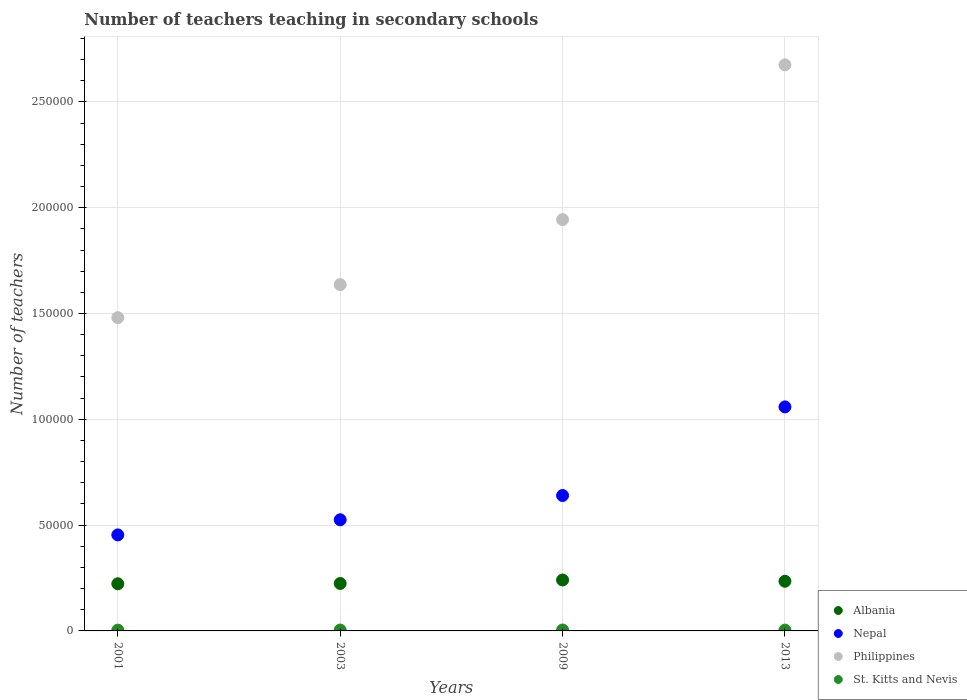How many different coloured dotlines are there?
Keep it short and to the point. 4. Is the number of dotlines equal to the number of legend labels?
Give a very brief answer. Yes. What is the number of teachers teaching in secondary schools in Philippines in 2009?
Your answer should be very brief. 1.94e+05. Across all years, what is the maximum number of teachers teaching in secondary schools in Albania?
Ensure brevity in your answer.  2.41e+04. Across all years, what is the minimum number of teachers teaching in secondary schools in St. Kitts and Nevis?
Your answer should be compact. 376. In which year was the number of teachers teaching in secondary schools in St. Kitts and Nevis maximum?
Your answer should be compact. 2009. What is the total number of teachers teaching in secondary schools in Philippines in the graph?
Keep it short and to the point. 7.74e+05. What is the difference between the number of teachers teaching in secondary schools in Albania in 2003 and that in 2009?
Your answer should be compact. -1645. What is the difference between the number of teachers teaching in secondary schools in Nepal in 2003 and the number of teachers teaching in secondary schools in St. Kitts and Nevis in 2009?
Offer a terse response. 5.21e+04. What is the average number of teachers teaching in secondary schools in Albania per year?
Offer a terse response. 2.31e+04. In the year 2009, what is the difference between the number of teachers teaching in secondary schools in Albania and number of teachers teaching in secondary schools in Philippines?
Your response must be concise. -1.70e+05. What is the ratio of the number of teachers teaching in secondary schools in Nepal in 2001 to that in 2003?
Offer a terse response. 0.86. Is the difference between the number of teachers teaching in secondary schools in Albania in 2003 and 2009 greater than the difference between the number of teachers teaching in secondary schools in Philippines in 2003 and 2009?
Ensure brevity in your answer.  Yes. What is the difference between the highest and the lowest number of teachers teaching in secondary schools in Philippines?
Keep it short and to the point. 1.19e+05. Is it the case that in every year, the sum of the number of teachers teaching in secondary schools in Nepal and number of teachers teaching in secondary schools in Philippines  is greater than the sum of number of teachers teaching in secondary schools in Albania and number of teachers teaching in secondary schools in St. Kitts and Nevis?
Ensure brevity in your answer.  No. Does the number of teachers teaching in secondary schools in Nepal monotonically increase over the years?
Make the answer very short. Yes. Is the number of teachers teaching in secondary schools in Philippines strictly greater than the number of teachers teaching in secondary schools in Albania over the years?
Keep it short and to the point. Yes. Are the values on the major ticks of Y-axis written in scientific E-notation?
Your response must be concise. No. How many legend labels are there?
Your answer should be compact. 4. How are the legend labels stacked?
Keep it short and to the point. Vertical. What is the title of the graph?
Provide a succinct answer. Number of teachers teaching in secondary schools. What is the label or title of the Y-axis?
Your answer should be compact. Number of teachers. What is the Number of teachers of Albania in 2001?
Offer a terse response. 2.23e+04. What is the Number of teachers in Nepal in 2001?
Provide a short and direct response. 4.54e+04. What is the Number of teachers in Philippines in 2001?
Your response must be concise. 1.48e+05. What is the Number of teachers of St. Kitts and Nevis in 2001?
Provide a succinct answer. 376. What is the Number of teachers of Albania in 2003?
Offer a terse response. 2.24e+04. What is the Number of teachers of Nepal in 2003?
Provide a short and direct response. 5.25e+04. What is the Number of teachers of Philippines in 2003?
Provide a short and direct response. 1.64e+05. What is the Number of teachers in St. Kitts and Nevis in 2003?
Your response must be concise. 417. What is the Number of teachers in Albania in 2009?
Give a very brief answer. 2.41e+04. What is the Number of teachers in Nepal in 2009?
Your response must be concise. 6.40e+04. What is the Number of teachers in Philippines in 2009?
Your response must be concise. 1.94e+05. What is the Number of teachers of St. Kitts and Nevis in 2009?
Your answer should be very brief. 441. What is the Number of teachers in Albania in 2013?
Provide a succinct answer. 2.35e+04. What is the Number of teachers of Nepal in 2013?
Ensure brevity in your answer.  1.06e+05. What is the Number of teachers in Philippines in 2013?
Make the answer very short. 2.68e+05. What is the Number of teachers of St. Kitts and Nevis in 2013?
Ensure brevity in your answer.  386. Across all years, what is the maximum Number of teachers of Albania?
Your answer should be very brief. 2.41e+04. Across all years, what is the maximum Number of teachers in Nepal?
Offer a terse response. 1.06e+05. Across all years, what is the maximum Number of teachers in Philippines?
Your answer should be compact. 2.68e+05. Across all years, what is the maximum Number of teachers of St. Kitts and Nevis?
Offer a terse response. 441. Across all years, what is the minimum Number of teachers in Albania?
Your response must be concise. 2.23e+04. Across all years, what is the minimum Number of teachers in Nepal?
Keep it short and to the point. 4.54e+04. Across all years, what is the minimum Number of teachers in Philippines?
Offer a very short reply. 1.48e+05. Across all years, what is the minimum Number of teachers of St. Kitts and Nevis?
Give a very brief answer. 376. What is the total Number of teachers in Albania in the graph?
Your answer should be very brief. 9.22e+04. What is the total Number of teachers of Nepal in the graph?
Provide a short and direct response. 2.68e+05. What is the total Number of teachers of Philippines in the graph?
Keep it short and to the point. 7.74e+05. What is the total Number of teachers in St. Kitts and Nevis in the graph?
Offer a very short reply. 1620. What is the difference between the Number of teachers in Albania in 2001 and that in 2003?
Your answer should be very brief. -144. What is the difference between the Number of teachers of Nepal in 2001 and that in 2003?
Your answer should be compact. -7155. What is the difference between the Number of teachers of Philippines in 2001 and that in 2003?
Your response must be concise. -1.56e+04. What is the difference between the Number of teachers of St. Kitts and Nevis in 2001 and that in 2003?
Provide a succinct answer. -41. What is the difference between the Number of teachers in Albania in 2001 and that in 2009?
Provide a succinct answer. -1789. What is the difference between the Number of teachers in Nepal in 2001 and that in 2009?
Provide a succinct answer. -1.86e+04. What is the difference between the Number of teachers in Philippines in 2001 and that in 2009?
Ensure brevity in your answer.  -4.63e+04. What is the difference between the Number of teachers of St. Kitts and Nevis in 2001 and that in 2009?
Provide a short and direct response. -65. What is the difference between the Number of teachers in Albania in 2001 and that in 2013?
Give a very brief answer. -1191. What is the difference between the Number of teachers in Nepal in 2001 and that in 2013?
Provide a succinct answer. -6.05e+04. What is the difference between the Number of teachers of Philippines in 2001 and that in 2013?
Make the answer very short. -1.19e+05. What is the difference between the Number of teachers of St. Kitts and Nevis in 2001 and that in 2013?
Your answer should be compact. -10. What is the difference between the Number of teachers of Albania in 2003 and that in 2009?
Ensure brevity in your answer.  -1645. What is the difference between the Number of teachers of Nepal in 2003 and that in 2009?
Provide a succinct answer. -1.15e+04. What is the difference between the Number of teachers of Philippines in 2003 and that in 2009?
Offer a very short reply. -3.07e+04. What is the difference between the Number of teachers in St. Kitts and Nevis in 2003 and that in 2009?
Offer a very short reply. -24. What is the difference between the Number of teachers of Albania in 2003 and that in 2013?
Ensure brevity in your answer.  -1047. What is the difference between the Number of teachers of Nepal in 2003 and that in 2013?
Make the answer very short. -5.33e+04. What is the difference between the Number of teachers in Philippines in 2003 and that in 2013?
Make the answer very short. -1.04e+05. What is the difference between the Number of teachers in St. Kitts and Nevis in 2003 and that in 2013?
Give a very brief answer. 31. What is the difference between the Number of teachers of Albania in 2009 and that in 2013?
Your answer should be very brief. 598. What is the difference between the Number of teachers in Nepal in 2009 and that in 2013?
Provide a short and direct response. -4.19e+04. What is the difference between the Number of teachers of Philippines in 2009 and that in 2013?
Keep it short and to the point. -7.31e+04. What is the difference between the Number of teachers of St. Kitts and Nevis in 2009 and that in 2013?
Your answer should be very brief. 55. What is the difference between the Number of teachers in Albania in 2001 and the Number of teachers in Nepal in 2003?
Give a very brief answer. -3.02e+04. What is the difference between the Number of teachers of Albania in 2001 and the Number of teachers of Philippines in 2003?
Ensure brevity in your answer.  -1.41e+05. What is the difference between the Number of teachers of Albania in 2001 and the Number of teachers of St. Kitts and Nevis in 2003?
Provide a short and direct response. 2.19e+04. What is the difference between the Number of teachers of Nepal in 2001 and the Number of teachers of Philippines in 2003?
Provide a short and direct response. -1.18e+05. What is the difference between the Number of teachers in Nepal in 2001 and the Number of teachers in St. Kitts and Nevis in 2003?
Give a very brief answer. 4.50e+04. What is the difference between the Number of teachers in Philippines in 2001 and the Number of teachers in St. Kitts and Nevis in 2003?
Keep it short and to the point. 1.48e+05. What is the difference between the Number of teachers in Albania in 2001 and the Number of teachers in Nepal in 2009?
Provide a short and direct response. -4.17e+04. What is the difference between the Number of teachers in Albania in 2001 and the Number of teachers in Philippines in 2009?
Offer a terse response. -1.72e+05. What is the difference between the Number of teachers in Albania in 2001 and the Number of teachers in St. Kitts and Nevis in 2009?
Give a very brief answer. 2.18e+04. What is the difference between the Number of teachers in Nepal in 2001 and the Number of teachers in Philippines in 2009?
Your response must be concise. -1.49e+05. What is the difference between the Number of teachers of Nepal in 2001 and the Number of teachers of St. Kitts and Nevis in 2009?
Provide a short and direct response. 4.49e+04. What is the difference between the Number of teachers of Philippines in 2001 and the Number of teachers of St. Kitts and Nevis in 2009?
Offer a very short reply. 1.48e+05. What is the difference between the Number of teachers of Albania in 2001 and the Number of teachers of Nepal in 2013?
Provide a succinct answer. -8.36e+04. What is the difference between the Number of teachers of Albania in 2001 and the Number of teachers of Philippines in 2013?
Offer a terse response. -2.45e+05. What is the difference between the Number of teachers in Albania in 2001 and the Number of teachers in St. Kitts and Nevis in 2013?
Your answer should be very brief. 2.19e+04. What is the difference between the Number of teachers of Nepal in 2001 and the Number of teachers of Philippines in 2013?
Provide a succinct answer. -2.22e+05. What is the difference between the Number of teachers of Nepal in 2001 and the Number of teachers of St. Kitts and Nevis in 2013?
Keep it short and to the point. 4.50e+04. What is the difference between the Number of teachers of Philippines in 2001 and the Number of teachers of St. Kitts and Nevis in 2013?
Give a very brief answer. 1.48e+05. What is the difference between the Number of teachers of Albania in 2003 and the Number of teachers of Nepal in 2009?
Offer a very short reply. -4.16e+04. What is the difference between the Number of teachers of Albania in 2003 and the Number of teachers of Philippines in 2009?
Your answer should be compact. -1.72e+05. What is the difference between the Number of teachers in Albania in 2003 and the Number of teachers in St. Kitts and Nevis in 2009?
Your response must be concise. 2.20e+04. What is the difference between the Number of teachers in Nepal in 2003 and the Number of teachers in Philippines in 2009?
Your response must be concise. -1.42e+05. What is the difference between the Number of teachers in Nepal in 2003 and the Number of teachers in St. Kitts and Nevis in 2009?
Your response must be concise. 5.21e+04. What is the difference between the Number of teachers in Philippines in 2003 and the Number of teachers in St. Kitts and Nevis in 2009?
Ensure brevity in your answer.  1.63e+05. What is the difference between the Number of teachers in Albania in 2003 and the Number of teachers in Nepal in 2013?
Ensure brevity in your answer.  -8.34e+04. What is the difference between the Number of teachers of Albania in 2003 and the Number of teachers of Philippines in 2013?
Your response must be concise. -2.45e+05. What is the difference between the Number of teachers in Albania in 2003 and the Number of teachers in St. Kitts and Nevis in 2013?
Give a very brief answer. 2.20e+04. What is the difference between the Number of teachers of Nepal in 2003 and the Number of teachers of Philippines in 2013?
Offer a very short reply. -2.15e+05. What is the difference between the Number of teachers of Nepal in 2003 and the Number of teachers of St. Kitts and Nevis in 2013?
Give a very brief answer. 5.21e+04. What is the difference between the Number of teachers in Philippines in 2003 and the Number of teachers in St. Kitts and Nevis in 2013?
Ensure brevity in your answer.  1.63e+05. What is the difference between the Number of teachers in Albania in 2009 and the Number of teachers in Nepal in 2013?
Provide a succinct answer. -8.18e+04. What is the difference between the Number of teachers of Albania in 2009 and the Number of teachers of Philippines in 2013?
Provide a succinct answer. -2.43e+05. What is the difference between the Number of teachers in Albania in 2009 and the Number of teachers in St. Kitts and Nevis in 2013?
Ensure brevity in your answer.  2.37e+04. What is the difference between the Number of teachers in Nepal in 2009 and the Number of teachers in Philippines in 2013?
Give a very brief answer. -2.04e+05. What is the difference between the Number of teachers of Nepal in 2009 and the Number of teachers of St. Kitts and Nevis in 2013?
Your answer should be very brief. 6.36e+04. What is the difference between the Number of teachers of Philippines in 2009 and the Number of teachers of St. Kitts and Nevis in 2013?
Provide a short and direct response. 1.94e+05. What is the average Number of teachers in Albania per year?
Your response must be concise. 2.31e+04. What is the average Number of teachers of Nepal per year?
Offer a very short reply. 6.69e+04. What is the average Number of teachers in Philippines per year?
Provide a short and direct response. 1.93e+05. What is the average Number of teachers of St. Kitts and Nevis per year?
Your answer should be compact. 405. In the year 2001, what is the difference between the Number of teachers of Albania and Number of teachers of Nepal?
Keep it short and to the point. -2.31e+04. In the year 2001, what is the difference between the Number of teachers in Albania and Number of teachers in Philippines?
Offer a terse response. -1.26e+05. In the year 2001, what is the difference between the Number of teachers of Albania and Number of teachers of St. Kitts and Nevis?
Offer a terse response. 2.19e+04. In the year 2001, what is the difference between the Number of teachers of Nepal and Number of teachers of Philippines?
Keep it short and to the point. -1.03e+05. In the year 2001, what is the difference between the Number of teachers of Nepal and Number of teachers of St. Kitts and Nevis?
Keep it short and to the point. 4.50e+04. In the year 2001, what is the difference between the Number of teachers of Philippines and Number of teachers of St. Kitts and Nevis?
Your response must be concise. 1.48e+05. In the year 2003, what is the difference between the Number of teachers in Albania and Number of teachers in Nepal?
Give a very brief answer. -3.01e+04. In the year 2003, what is the difference between the Number of teachers in Albania and Number of teachers in Philippines?
Make the answer very short. -1.41e+05. In the year 2003, what is the difference between the Number of teachers of Albania and Number of teachers of St. Kitts and Nevis?
Provide a succinct answer. 2.20e+04. In the year 2003, what is the difference between the Number of teachers of Nepal and Number of teachers of Philippines?
Give a very brief answer. -1.11e+05. In the year 2003, what is the difference between the Number of teachers in Nepal and Number of teachers in St. Kitts and Nevis?
Your answer should be compact. 5.21e+04. In the year 2003, what is the difference between the Number of teachers of Philippines and Number of teachers of St. Kitts and Nevis?
Provide a short and direct response. 1.63e+05. In the year 2009, what is the difference between the Number of teachers in Albania and Number of teachers in Nepal?
Provide a short and direct response. -3.99e+04. In the year 2009, what is the difference between the Number of teachers in Albania and Number of teachers in Philippines?
Your answer should be very brief. -1.70e+05. In the year 2009, what is the difference between the Number of teachers in Albania and Number of teachers in St. Kitts and Nevis?
Offer a terse response. 2.36e+04. In the year 2009, what is the difference between the Number of teachers in Nepal and Number of teachers in Philippines?
Ensure brevity in your answer.  -1.30e+05. In the year 2009, what is the difference between the Number of teachers in Nepal and Number of teachers in St. Kitts and Nevis?
Your answer should be compact. 6.36e+04. In the year 2009, what is the difference between the Number of teachers of Philippines and Number of teachers of St. Kitts and Nevis?
Your answer should be very brief. 1.94e+05. In the year 2013, what is the difference between the Number of teachers of Albania and Number of teachers of Nepal?
Your answer should be very brief. -8.24e+04. In the year 2013, what is the difference between the Number of teachers in Albania and Number of teachers in Philippines?
Offer a terse response. -2.44e+05. In the year 2013, what is the difference between the Number of teachers in Albania and Number of teachers in St. Kitts and Nevis?
Give a very brief answer. 2.31e+04. In the year 2013, what is the difference between the Number of teachers of Nepal and Number of teachers of Philippines?
Keep it short and to the point. -1.62e+05. In the year 2013, what is the difference between the Number of teachers in Nepal and Number of teachers in St. Kitts and Nevis?
Keep it short and to the point. 1.05e+05. In the year 2013, what is the difference between the Number of teachers in Philippines and Number of teachers in St. Kitts and Nevis?
Ensure brevity in your answer.  2.67e+05. What is the ratio of the Number of teachers in Albania in 2001 to that in 2003?
Your answer should be very brief. 0.99. What is the ratio of the Number of teachers of Nepal in 2001 to that in 2003?
Give a very brief answer. 0.86. What is the ratio of the Number of teachers in Philippines in 2001 to that in 2003?
Provide a short and direct response. 0.9. What is the ratio of the Number of teachers in St. Kitts and Nevis in 2001 to that in 2003?
Offer a terse response. 0.9. What is the ratio of the Number of teachers in Albania in 2001 to that in 2009?
Provide a succinct answer. 0.93. What is the ratio of the Number of teachers of Nepal in 2001 to that in 2009?
Provide a succinct answer. 0.71. What is the ratio of the Number of teachers in Philippines in 2001 to that in 2009?
Offer a very short reply. 0.76. What is the ratio of the Number of teachers of St. Kitts and Nevis in 2001 to that in 2009?
Provide a short and direct response. 0.85. What is the ratio of the Number of teachers of Albania in 2001 to that in 2013?
Offer a very short reply. 0.95. What is the ratio of the Number of teachers in Nepal in 2001 to that in 2013?
Keep it short and to the point. 0.43. What is the ratio of the Number of teachers of Philippines in 2001 to that in 2013?
Make the answer very short. 0.55. What is the ratio of the Number of teachers in St. Kitts and Nevis in 2001 to that in 2013?
Ensure brevity in your answer.  0.97. What is the ratio of the Number of teachers in Albania in 2003 to that in 2009?
Your response must be concise. 0.93. What is the ratio of the Number of teachers of Nepal in 2003 to that in 2009?
Ensure brevity in your answer.  0.82. What is the ratio of the Number of teachers of Philippines in 2003 to that in 2009?
Your response must be concise. 0.84. What is the ratio of the Number of teachers of St. Kitts and Nevis in 2003 to that in 2009?
Give a very brief answer. 0.95. What is the ratio of the Number of teachers of Albania in 2003 to that in 2013?
Keep it short and to the point. 0.96. What is the ratio of the Number of teachers of Nepal in 2003 to that in 2013?
Offer a very short reply. 0.5. What is the ratio of the Number of teachers of Philippines in 2003 to that in 2013?
Ensure brevity in your answer.  0.61. What is the ratio of the Number of teachers in St. Kitts and Nevis in 2003 to that in 2013?
Give a very brief answer. 1.08. What is the ratio of the Number of teachers in Albania in 2009 to that in 2013?
Make the answer very short. 1.03. What is the ratio of the Number of teachers in Nepal in 2009 to that in 2013?
Keep it short and to the point. 0.6. What is the ratio of the Number of teachers in Philippines in 2009 to that in 2013?
Provide a short and direct response. 0.73. What is the ratio of the Number of teachers in St. Kitts and Nevis in 2009 to that in 2013?
Offer a terse response. 1.14. What is the difference between the highest and the second highest Number of teachers in Albania?
Make the answer very short. 598. What is the difference between the highest and the second highest Number of teachers of Nepal?
Your answer should be compact. 4.19e+04. What is the difference between the highest and the second highest Number of teachers of Philippines?
Your answer should be compact. 7.31e+04. What is the difference between the highest and the second highest Number of teachers of St. Kitts and Nevis?
Your answer should be very brief. 24. What is the difference between the highest and the lowest Number of teachers in Albania?
Provide a short and direct response. 1789. What is the difference between the highest and the lowest Number of teachers of Nepal?
Ensure brevity in your answer.  6.05e+04. What is the difference between the highest and the lowest Number of teachers in Philippines?
Your answer should be very brief. 1.19e+05. What is the difference between the highest and the lowest Number of teachers in St. Kitts and Nevis?
Offer a terse response. 65. 